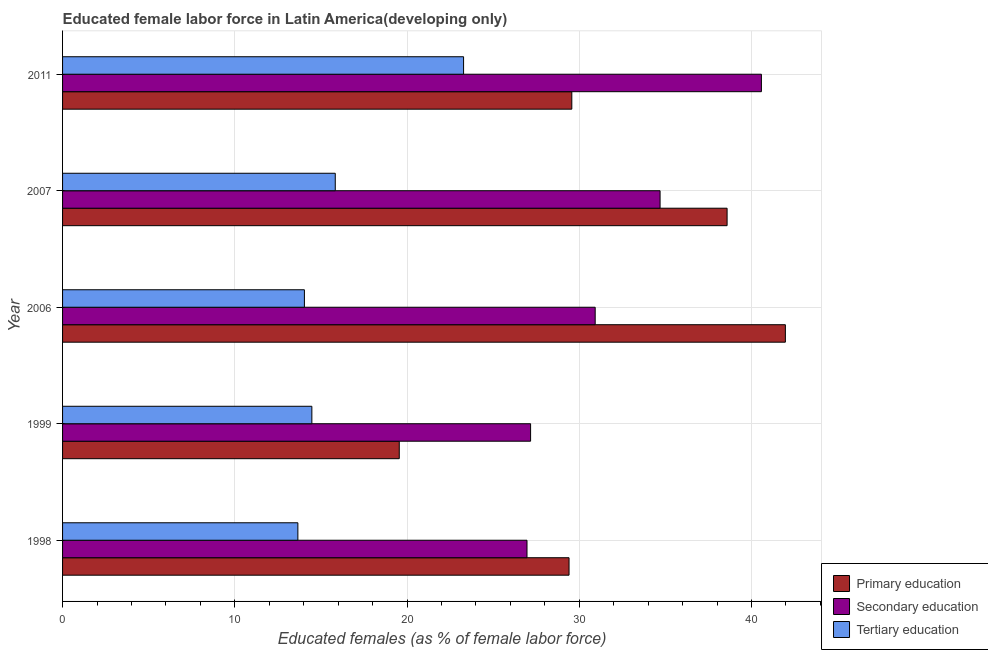How many different coloured bars are there?
Give a very brief answer. 3. Are the number of bars on each tick of the Y-axis equal?
Make the answer very short. Yes. In how many cases, is the number of bars for a given year not equal to the number of legend labels?
Give a very brief answer. 0. What is the percentage of female labor force who received primary education in 2007?
Offer a terse response. 38.59. Across all years, what is the maximum percentage of female labor force who received tertiary education?
Your answer should be very brief. 23.28. Across all years, what is the minimum percentage of female labor force who received primary education?
Keep it short and to the point. 19.55. In which year was the percentage of female labor force who received primary education maximum?
Offer a terse response. 2006. What is the total percentage of female labor force who received tertiary education in the graph?
Your response must be concise. 81.3. What is the difference between the percentage of female labor force who received secondary education in 1999 and that in 2006?
Make the answer very short. -3.75. What is the difference between the percentage of female labor force who received primary education in 1999 and the percentage of female labor force who received secondary education in 2006?
Offer a terse response. -11.38. What is the average percentage of female labor force who received tertiary education per year?
Keep it short and to the point. 16.26. In the year 1998, what is the difference between the percentage of female labor force who received secondary education and percentage of female labor force who received tertiary education?
Offer a very short reply. 13.3. In how many years, is the percentage of female labor force who received primary education greater than 42 %?
Keep it short and to the point. 0. What is the ratio of the percentage of female labor force who received primary education in 1999 to that in 2006?
Offer a terse response. 0.47. Is the difference between the percentage of female labor force who received primary education in 1999 and 2007 greater than the difference between the percentage of female labor force who received secondary education in 1999 and 2007?
Offer a very short reply. No. What is the difference between the highest and the second highest percentage of female labor force who received primary education?
Offer a very short reply. 3.38. What is the difference between the highest and the lowest percentage of female labor force who received primary education?
Offer a terse response. 22.42. In how many years, is the percentage of female labor force who received secondary education greater than the average percentage of female labor force who received secondary education taken over all years?
Your response must be concise. 2. What does the 3rd bar from the top in 2011 represents?
Make the answer very short. Primary education. What does the 2nd bar from the bottom in 1999 represents?
Offer a terse response. Secondary education. Are all the bars in the graph horizontal?
Offer a very short reply. Yes. What is the difference between two consecutive major ticks on the X-axis?
Keep it short and to the point. 10. Are the values on the major ticks of X-axis written in scientific E-notation?
Provide a succinct answer. No. How are the legend labels stacked?
Provide a succinct answer. Vertical. What is the title of the graph?
Your answer should be very brief. Educated female labor force in Latin America(developing only). What is the label or title of the X-axis?
Provide a succinct answer. Educated females (as % of female labor force). What is the label or title of the Y-axis?
Make the answer very short. Year. What is the Educated females (as % of female labor force) of Primary education in 1998?
Ensure brevity in your answer.  29.41. What is the Educated females (as % of female labor force) of Secondary education in 1998?
Give a very brief answer. 26.97. What is the Educated females (as % of female labor force) in Tertiary education in 1998?
Provide a short and direct response. 13.66. What is the Educated females (as % of female labor force) in Primary education in 1999?
Provide a short and direct response. 19.55. What is the Educated females (as % of female labor force) of Secondary education in 1999?
Your answer should be very brief. 27.18. What is the Educated females (as % of female labor force) of Tertiary education in 1999?
Give a very brief answer. 14.48. What is the Educated females (as % of female labor force) of Primary education in 2006?
Your answer should be very brief. 41.97. What is the Educated females (as % of female labor force) in Secondary education in 2006?
Ensure brevity in your answer.  30.93. What is the Educated females (as % of female labor force) of Tertiary education in 2006?
Provide a succinct answer. 14.04. What is the Educated females (as % of female labor force) in Primary education in 2007?
Your response must be concise. 38.59. What is the Educated females (as % of female labor force) of Secondary education in 2007?
Your answer should be compact. 34.69. What is the Educated females (as % of female labor force) of Tertiary education in 2007?
Offer a very short reply. 15.83. What is the Educated females (as % of female labor force) in Primary education in 2011?
Your answer should be very brief. 29.57. What is the Educated females (as % of female labor force) in Secondary education in 2011?
Your response must be concise. 40.58. What is the Educated females (as % of female labor force) of Tertiary education in 2011?
Provide a succinct answer. 23.28. Across all years, what is the maximum Educated females (as % of female labor force) of Primary education?
Give a very brief answer. 41.97. Across all years, what is the maximum Educated females (as % of female labor force) of Secondary education?
Your answer should be very brief. 40.58. Across all years, what is the maximum Educated females (as % of female labor force) in Tertiary education?
Your answer should be very brief. 23.28. Across all years, what is the minimum Educated females (as % of female labor force) of Primary education?
Give a very brief answer. 19.55. Across all years, what is the minimum Educated females (as % of female labor force) in Secondary education?
Ensure brevity in your answer.  26.97. Across all years, what is the minimum Educated females (as % of female labor force) of Tertiary education?
Provide a short and direct response. 13.66. What is the total Educated females (as % of female labor force) in Primary education in the graph?
Give a very brief answer. 159.09. What is the total Educated females (as % of female labor force) of Secondary education in the graph?
Offer a very short reply. 160.35. What is the total Educated females (as % of female labor force) of Tertiary education in the graph?
Your response must be concise. 81.3. What is the difference between the Educated females (as % of female labor force) of Primary education in 1998 and that in 1999?
Your answer should be compact. 9.86. What is the difference between the Educated females (as % of female labor force) in Secondary education in 1998 and that in 1999?
Give a very brief answer. -0.21. What is the difference between the Educated females (as % of female labor force) in Tertiary education in 1998 and that in 1999?
Your answer should be compact. -0.81. What is the difference between the Educated females (as % of female labor force) in Primary education in 1998 and that in 2006?
Offer a terse response. -12.56. What is the difference between the Educated females (as % of female labor force) of Secondary education in 1998 and that in 2006?
Offer a terse response. -3.96. What is the difference between the Educated females (as % of female labor force) of Tertiary education in 1998 and that in 2006?
Give a very brief answer. -0.38. What is the difference between the Educated females (as % of female labor force) of Primary education in 1998 and that in 2007?
Give a very brief answer. -9.18. What is the difference between the Educated females (as % of female labor force) in Secondary education in 1998 and that in 2007?
Ensure brevity in your answer.  -7.73. What is the difference between the Educated females (as % of female labor force) of Tertiary education in 1998 and that in 2007?
Your response must be concise. -2.17. What is the difference between the Educated females (as % of female labor force) in Primary education in 1998 and that in 2011?
Give a very brief answer. -0.16. What is the difference between the Educated females (as % of female labor force) of Secondary education in 1998 and that in 2011?
Offer a very short reply. -13.61. What is the difference between the Educated females (as % of female labor force) in Tertiary education in 1998 and that in 2011?
Provide a succinct answer. -9.62. What is the difference between the Educated females (as % of female labor force) of Primary education in 1999 and that in 2006?
Keep it short and to the point. -22.42. What is the difference between the Educated females (as % of female labor force) in Secondary education in 1999 and that in 2006?
Give a very brief answer. -3.75. What is the difference between the Educated females (as % of female labor force) of Tertiary education in 1999 and that in 2006?
Offer a very short reply. 0.43. What is the difference between the Educated females (as % of female labor force) of Primary education in 1999 and that in 2007?
Make the answer very short. -19.04. What is the difference between the Educated females (as % of female labor force) of Secondary education in 1999 and that in 2007?
Offer a terse response. -7.52. What is the difference between the Educated females (as % of female labor force) of Tertiary education in 1999 and that in 2007?
Offer a very short reply. -1.36. What is the difference between the Educated females (as % of female labor force) of Primary education in 1999 and that in 2011?
Make the answer very short. -10.02. What is the difference between the Educated females (as % of female labor force) in Secondary education in 1999 and that in 2011?
Offer a terse response. -13.4. What is the difference between the Educated females (as % of female labor force) in Tertiary education in 1999 and that in 2011?
Make the answer very short. -8.81. What is the difference between the Educated females (as % of female labor force) of Primary education in 2006 and that in 2007?
Your response must be concise. 3.38. What is the difference between the Educated females (as % of female labor force) of Secondary education in 2006 and that in 2007?
Offer a very short reply. -3.77. What is the difference between the Educated females (as % of female labor force) of Tertiary education in 2006 and that in 2007?
Give a very brief answer. -1.79. What is the difference between the Educated females (as % of female labor force) in Primary education in 2006 and that in 2011?
Give a very brief answer. 12.4. What is the difference between the Educated females (as % of female labor force) in Secondary education in 2006 and that in 2011?
Your response must be concise. -9.65. What is the difference between the Educated females (as % of female labor force) of Tertiary education in 2006 and that in 2011?
Give a very brief answer. -9.24. What is the difference between the Educated females (as % of female labor force) of Primary education in 2007 and that in 2011?
Give a very brief answer. 9.02. What is the difference between the Educated females (as % of female labor force) in Secondary education in 2007 and that in 2011?
Provide a succinct answer. -5.88. What is the difference between the Educated females (as % of female labor force) of Tertiary education in 2007 and that in 2011?
Make the answer very short. -7.45. What is the difference between the Educated females (as % of female labor force) of Primary education in 1998 and the Educated females (as % of female labor force) of Secondary education in 1999?
Provide a short and direct response. 2.23. What is the difference between the Educated females (as % of female labor force) of Primary education in 1998 and the Educated females (as % of female labor force) of Tertiary education in 1999?
Your response must be concise. 14.93. What is the difference between the Educated females (as % of female labor force) in Secondary education in 1998 and the Educated females (as % of female labor force) in Tertiary education in 1999?
Provide a succinct answer. 12.49. What is the difference between the Educated females (as % of female labor force) of Primary education in 1998 and the Educated females (as % of female labor force) of Secondary education in 2006?
Keep it short and to the point. -1.52. What is the difference between the Educated females (as % of female labor force) in Primary education in 1998 and the Educated females (as % of female labor force) in Tertiary education in 2006?
Keep it short and to the point. 15.37. What is the difference between the Educated females (as % of female labor force) in Secondary education in 1998 and the Educated females (as % of female labor force) in Tertiary education in 2006?
Your answer should be very brief. 12.93. What is the difference between the Educated females (as % of female labor force) of Primary education in 1998 and the Educated females (as % of female labor force) of Secondary education in 2007?
Give a very brief answer. -5.29. What is the difference between the Educated females (as % of female labor force) of Primary education in 1998 and the Educated females (as % of female labor force) of Tertiary education in 2007?
Keep it short and to the point. 13.57. What is the difference between the Educated females (as % of female labor force) in Secondary education in 1998 and the Educated females (as % of female labor force) in Tertiary education in 2007?
Offer a very short reply. 11.13. What is the difference between the Educated females (as % of female labor force) in Primary education in 1998 and the Educated females (as % of female labor force) in Secondary education in 2011?
Ensure brevity in your answer.  -11.17. What is the difference between the Educated females (as % of female labor force) of Primary education in 1998 and the Educated females (as % of female labor force) of Tertiary education in 2011?
Provide a short and direct response. 6.12. What is the difference between the Educated females (as % of female labor force) in Secondary education in 1998 and the Educated females (as % of female labor force) in Tertiary education in 2011?
Offer a very short reply. 3.68. What is the difference between the Educated females (as % of female labor force) in Primary education in 1999 and the Educated females (as % of female labor force) in Secondary education in 2006?
Ensure brevity in your answer.  -11.38. What is the difference between the Educated females (as % of female labor force) of Primary education in 1999 and the Educated females (as % of female labor force) of Tertiary education in 2006?
Give a very brief answer. 5.51. What is the difference between the Educated females (as % of female labor force) of Secondary education in 1999 and the Educated females (as % of female labor force) of Tertiary education in 2006?
Keep it short and to the point. 13.13. What is the difference between the Educated females (as % of female labor force) of Primary education in 1999 and the Educated females (as % of female labor force) of Secondary education in 2007?
Your answer should be very brief. -15.14. What is the difference between the Educated females (as % of female labor force) in Primary education in 1999 and the Educated females (as % of female labor force) in Tertiary education in 2007?
Make the answer very short. 3.72. What is the difference between the Educated females (as % of female labor force) in Secondary education in 1999 and the Educated females (as % of female labor force) in Tertiary education in 2007?
Provide a succinct answer. 11.34. What is the difference between the Educated females (as % of female labor force) in Primary education in 1999 and the Educated females (as % of female labor force) in Secondary education in 2011?
Your answer should be very brief. -21.03. What is the difference between the Educated females (as % of female labor force) of Primary education in 1999 and the Educated females (as % of female labor force) of Tertiary education in 2011?
Give a very brief answer. -3.73. What is the difference between the Educated females (as % of female labor force) of Secondary education in 1999 and the Educated females (as % of female labor force) of Tertiary education in 2011?
Provide a short and direct response. 3.89. What is the difference between the Educated females (as % of female labor force) in Primary education in 2006 and the Educated females (as % of female labor force) in Secondary education in 2007?
Provide a short and direct response. 7.28. What is the difference between the Educated females (as % of female labor force) of Primary education in 2006 and the Educated females (as % of female labor force) of Tertiary education in 2007?
Offer a very short reply. 26.14. What is the difference between the Educated females (as % of female labor force) of Secondary education in 2006 and the Educated females (as % of female labor force) of Tertiary education in 2007?
Your answer should be very brief. 15.09. What is the difference between the Educated females (as % of female labor force) of Primary education in 2006 and the Educated females (as % of female labor force) of Secondary education in 2011?
Make the answer very short. 1.39. What is the difference between the Educated females (as % of female labor force) of Primary education in 2006 and the Educated females (as % of female labor force) of Tertiary education in 2011?
Keep it short and to the point. 18.68. What is the difference between the Educated females (as % of female labor force) in Secondary education in 2006 and the Educated females (as % of female labor force) in Tertiary education in 2011?
Keep it short and to the point. 7.64. What is the difference between the Educated females (as % of female labor force) in Primary education in 2007 and the Educated females (as % of female labor force) in Secondary education in 2011?
Your response must be concise. -1.99. What is the difference between the Educated females (as % of female labor force) of Primary education in 2007 and the Educated females (as % of female labor force) of Tertiary education in 2011?
Ensure brevity in your answer.  15.3. What is the difference between the Educated females (as % of female labor force) in Secondary education in 2007 and the Educated females (as % of female labor force) in Tertiary education in 2011?
Your response must be concise. 11.41. What is the average Educated females (as % of female labor force) in Primary education per year?
Provide a short and direct response. 31.82. What is the average Educated females (as % of female labor force) of Secondary education per year?
Give a very brief answer. 32.07. What is the average Educated females (as % of female labor force) in Tertiary education per year?
Provide a succinct answer. 16.26. In the year 1998, what is the difference between the Educated females (as % of female labor force) of Primary education and Educated females (as % of female labor force) of Secondary education?
Make the answer very short. 2.44. In the year 1998, what is the difference between the Educated females (as % of female labor force) of Primary education and Educated females (as % of female labor force) of Tertiary education?
Offer a terse response. 15.75. In the year 1998, what is the difference between the Educated females (as % of female labor force) of Secondary education and Educated females (as % of female labor force) of Tertiary education?
Your response must be concise. 13.3. In the year 1999, what is the difference between the Educated females (as % of female labor force) in Primary education and Educated females (as % of female labor force) in Secondary education?
Keep it short and to the point. -7.63. In the year 1999, what is the difference between the Educated females (as % of female labor force) of Primary education and Educated females (as % of female labor force) of Tertiary education?
Your answer should be very brief. 5.08. In the year 1999, what is the difference between the Educated females (as % of female labor force) of Secondary education and Educated females (as % of female labor force) of Tertiary education?
Your response must be concise. 12.7. In the year 2006, what is the difference between the Educated females (as % of female labor force) in Primary education and Educated females (as % of female labor force) in Secondary education?
Make the answer very short. 11.04. In the year 2006, what is the difference between the Educated females (as % of female labor force) of Primary education and Educated females (as % of female labor force) of Tertiary education?
Give a very brief answer. 27.93. In the year 2006, what is the difference between the Educated females (as % of female labor force) in Secondary education and Educated females (as % of female labor force) in Tertiary education?
Give a very brief answer. 16.88. In the year 2007, what is the difference between the Educated females (as % of female labor force) in Primary education and Educated females (as % of female labor force) in Secondary education?
Give a very brief answer. 3.89. In the year 2007, what is the difference between the Educated females (as % of female labor force) in Primary education and Educated females (as % of female labor force) in Tertiary education?
Make the answer very short. 22.75. In the year 2007, what is the difference between the Educated females (as % of female labor force) in Secondary education and Educated females (as % of female labor force) in Tertiary education?
Make the answer very short. 18.86. In the year 2011, what is the difference between the Educated females (as % of female labor force) in Primary education and Educated females (as % of female labor force) in Secondary education?
Your response must be concise. -11.01. In the year 2011, what is the difference between the Educated females (as % of female labor force) of Primary education and Educated females (as % of female labor force) of Tertiary education?
Provide a succinct answer. 6.29. In the year 2011, what is the difference between the Educated females (as % of female labor force) in Secondary education and Educated females (as % of female labor force) in Tertiary education?
Offer a very short reply. 17.29. What is the ratio of the Educated females (as % of female labor force) of Primary education in 1998 to that in 1999?
Keep it short and to the point. 1.5. What is the ratio of the Educated females (as % of female labor force) of Tertiary education in 1998 to that in 1999?
Provide a short and direct response. 0.94. What is the ratio of the Educated females (as % of female labor force) of Primary education in 1998 to that in 2006?
Your answer should be compact. 0.7. What is the ratio of the Educated females (as % of female labor force) of Secondary education in 1998 to that in 2006?
Offer a very short reply. 0.87. What is the ratio of the Educated females (as % of female labor force) of Primary education in 1998 to that in 2007?
Provide a short and direct response. 0.76. What is the ratio of the Educated females (as % of female labor force) in Secondary education in 1998 to that in 2007?
Offer a terse response. 0.78. What is the ratio of the Educated females (as % of female labor force) in Tertiary education in 1998 to that in 2007?
Provide a succinct answer. 0.86. What is the ratio of the Educated females (as % of female labor force) in Secondary education in 1998 to that in 2011?
Provide a succinct answer. 0.66. What is the ratio of the Educated females (as % of female labor force) of Tertiary education in 1998 to that in 2011?
Your answer should be very brief. 0.59. What is the ratio of the Educated females (as % of female labor force) of Primary education in 1999 to that in 2006?
Your answer should be compact. 0.47. What is the ratio of the Educated females (as % of female labor force) of Secondary education in 1999 to that in 2006?
Offer a terse response. 0.88. What is the ratio of the Educated females (as % of female labor force) of Tertiary education in 1999 to that in 2006?
Give a very brief answer. 1.03. What is the ratio of the Educated females (as % of female labor force) of Primary education in 1999 to that in 2007?
Your answer should be very brief. 0.51. What is the ratio of the Educated females (as % of female labor force) in Secondary education in 1999 to that in 2007?
Keep it short and to the point. 0.78. What is the ratio of the Educated females (as % of female labor force) of Tertiary education in 1999 to that in 2007?
Provide a short and direct response. 0.91. What is the ratio of the Educated females (as % of female labor force) of Primary education in 1999 to that in 2011?
Keep it short and to the point. 0.66. What is the ratio of the Educated females (as % of female labor force) of Secondary education in 1999 to that in 2011?
Provide a succinct answer. 0.67. What is the ratio of the Educated females (as % of female labor force) in Tertiary education in 1999 to that in 2011?
Provide a succinct answer. 0.62. What is the ratio of the Educated females (as % of female labor force) of Primary education in 2006 to that in 2007?
Offer a very short reply. 1.09. What is the ratio of the Educated females (as % of female labor force) in Secondary education in 2006 to that in 2007?
Offer a terse response. 0.89. What is the ratio of the Educated females (as % of female labor force) in Tertiary education in 2006 to that in 2007?
Give a very brief answer. 0.89. What is the ratio of the Educated females (as % of female labor force) of Primary education in 2006 to that in 2011?
Offer a terse response. 1.42. What is the ratio of the Educated females (as % of female labor force) in Secondary education in 2006 to that in 2011?
Give a very brief answer. 0.76. What is the ratio of the Educated females (as % of female labor force) of Tertiary education in 2006 to that in 2011?
Your answer should be very brief. 0.6. What is the ratio of the Educated females (as % of female labor force) of Primary education in 2007 to that in 2011?
Offer a terse response. 1.3. What is the ratio of the Educated females (as % of female labor force) of Secondary education in 2007 to that in 2011?
Give a very brief answer. 0.85. What is the ratio of the Educated females (as % of female labor force) in Tertiary education in 2007 to that in 2011?
Offer a very short reply. 0.68. What is the difference between the highest and the second highest Educated females (as % of female labor force) of Primary education?
Ensure brevity in your answer.  3.38. What is the difference between the highest and the second highest Educated females (as % of female labor force) in Secondary education?
Provide a succinct answer. 5.88. What is the difference between the highest and the second highest Educated females (as % of female labor force) of Tertiary education?
Provide a short and direct response. 7.45. What is the difference between the highest and the lowest Educated females (as % of female labor force) of Primary education?
Offer a terse response. 22.42. What is the difference between the highest and the lowest Educated females (as % of female labor force) of Secondary education?
Offer a terse response. 13.61. What is the difference between the highest and the lowest Educated females (as % of female labor force) in Tertiary education?
Your answer should be very brief. 9.62. 